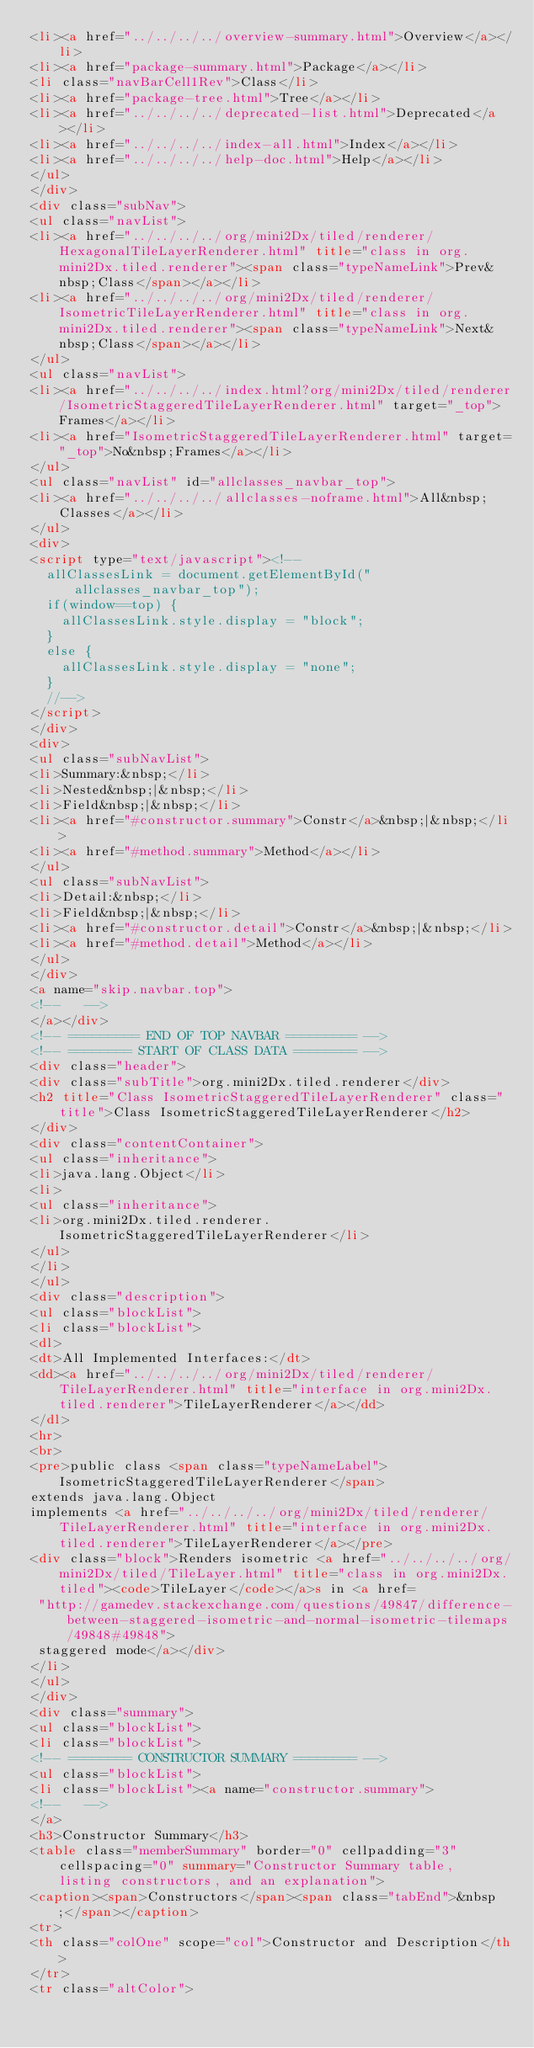Convert code to text. <code><loc_0><loc_0><loc_500><loc_500><_HTML_><li><a href="../../../../overview-summary.html">Overview</a></li>
<li><a href="package-summary.html">Package</a></li>
<li class="navBarCell1Rev">Class</li>
<li><a href="package-tree.html">Tree</a></li>
<li><a href="../../../../deprecated-list.html">Deprecated</a></li>
<li><a href="../../../../index-all.html">Index</a></li>
<li><a href="../../../../help-doc.html">Help</a></li>
</ul>
</div>
<div class="subNav">
<ul class="navList">
<li><a href="../../../../org/mini2Dx/tiled/renderer/HexagonalTileLayerRenderer.html" title="class in org.mini2Dx.tiled.renderer"><span class="typeNameLink">Prev&nbsp;Class</span></a></li>
<li><a href="../../../../org/mini2Dx/tiled/renderer/IsometricTileLayerRenderer.html" title="class in org.mini2Dx.tiled.renderer"><span class="typeNameLink">Next&nbsp;Class</span></a></li>
</ul>
<ul class="navList">
<li><a href="../../../../index.html?org/mini2Dx/tiled/renderer/IsometricStaggeredTileLayerRenderer.html" target="_top">Frames</a></li>
<li><a href="IsometricStaggeredTileLayerRenderer.html" target="_top">No&nbsp;Frames</a></li>
</ul>
<ul class="navList" id="allclasses_navbar_top">
<li><a href="../../../../allclasses-noframe.html">All&nbsp;Classes</a></li>
</ul>
<div>
<script type="text/javascript"><!--
  allClassesLink = document.getElementById("allclasses_navbar_top");
  if(window==top) {
    allClassesLink.style.display = "block";
  }
  else {
    allClassesLink.style.display = "none";
  }
  //-->
</script>
</div>
<div>
<ul class="subNavList">
<li>Summary:&nbsp;</li>
<li>Nested&nbsp;|&nbsp;</li>
<li>Field&nbsp;|&nbsp;</li>
<li><a href="#constructor.summary">Constr</a>&nbsp;|&nbsp;</li>
<li><a href="#method.summary">Method</a></li>
</ul>
<ul class="subNavList">
<li>Detail:&nbsp;</li>
<li>Field&nbsp;|&nbsp;</li>
<li><a href="#constructor.detail">Constr</a>&nbsp;|&nbsp;</li>
<li><a href="#method.detail">Method</a></li>
</ul>
</div>
<a name="skip.navbar.top">
<!--   -->
</a></div>
<!-- ========= END OF TOP NAVBAR ========= -->
<!-- ======== START OF CLASS DATA ======== -->
<div class="header">
<div class="subTitle">org.mini2Dx.tiled.renderer</div>
<h2 title="Class IsometricStaggeredTileLayerRenderer" class="title">Class IsometricStaggeredTileLayerRenderer</h2>
</div>
<div class="contentContainer">
<ul class="inheritance">
<li>java.lang.Object</li>
<li>
<ul class="inheritance">
<li>org.mini2Dx.tiled.renderer.IsometricStaggeredTileLayerRenderer</li>
</ul>
</li>
</ul>
<div class="description">
<ul class="blockList">
<li class="blockList">
<dl>
<dt>All Implemented Interfaces:</dt>
<dd><a href="../../../../org/mini2Dx/tiled/renderer/TileLayerRenderer.html" title="interface in org.mini2Dx.tiled.renderer">TileLayerRenderer</a></dd>
</dl>
<hr>
<br>
<pre>public class <span class="typeNameLabel">IsometricStaggeredTileLayerRenderer</span>
extends java.lang.Object
implements <a href="../../../../org/mini2Dx/tiled/renderer/TileLayerRenderer.html" title="interface in org.mini2Dx.tiled.renderer">TileLayerRenderer</a></pre>
<div class="block">Renders isometric <a href="../../../../org/mini2Dx/tiled/TileLayer.html" title="class in org.mini2Dx.tiled"><code>TileLayer</code></a>s in <a href=
 "http://gamedev.stackexchange.com/questions/49847/difference-between-staggered-isometric-and-normal-isometric-tilemaps/49848#49848">
 staggered mode</a></div>
</li>
</ul>
</div>
<div class="summary">
<ul class="blockList">
<li class="blockList">
<!-- ======== CONSTRUCTOR SUMMARY ======== -->
<ul class="blockList">
<li class="blockList"><a name="constructor.summary">
<!--   -->
</a>
<h3>Constructor Summary</h3>
<table class="memberSummary" border="0" cellpadding="3" cellspacing="0" summary="Constructor Summary table, listing constructors, and an explanation">
<caption><span>Constructors</span><span class="tabEnd">&nbsp;</span></caption>
<tr>
<th class="colOne" scope="col">Constructor and Description</th>
</tr>
<tr class="altColor"></code> 